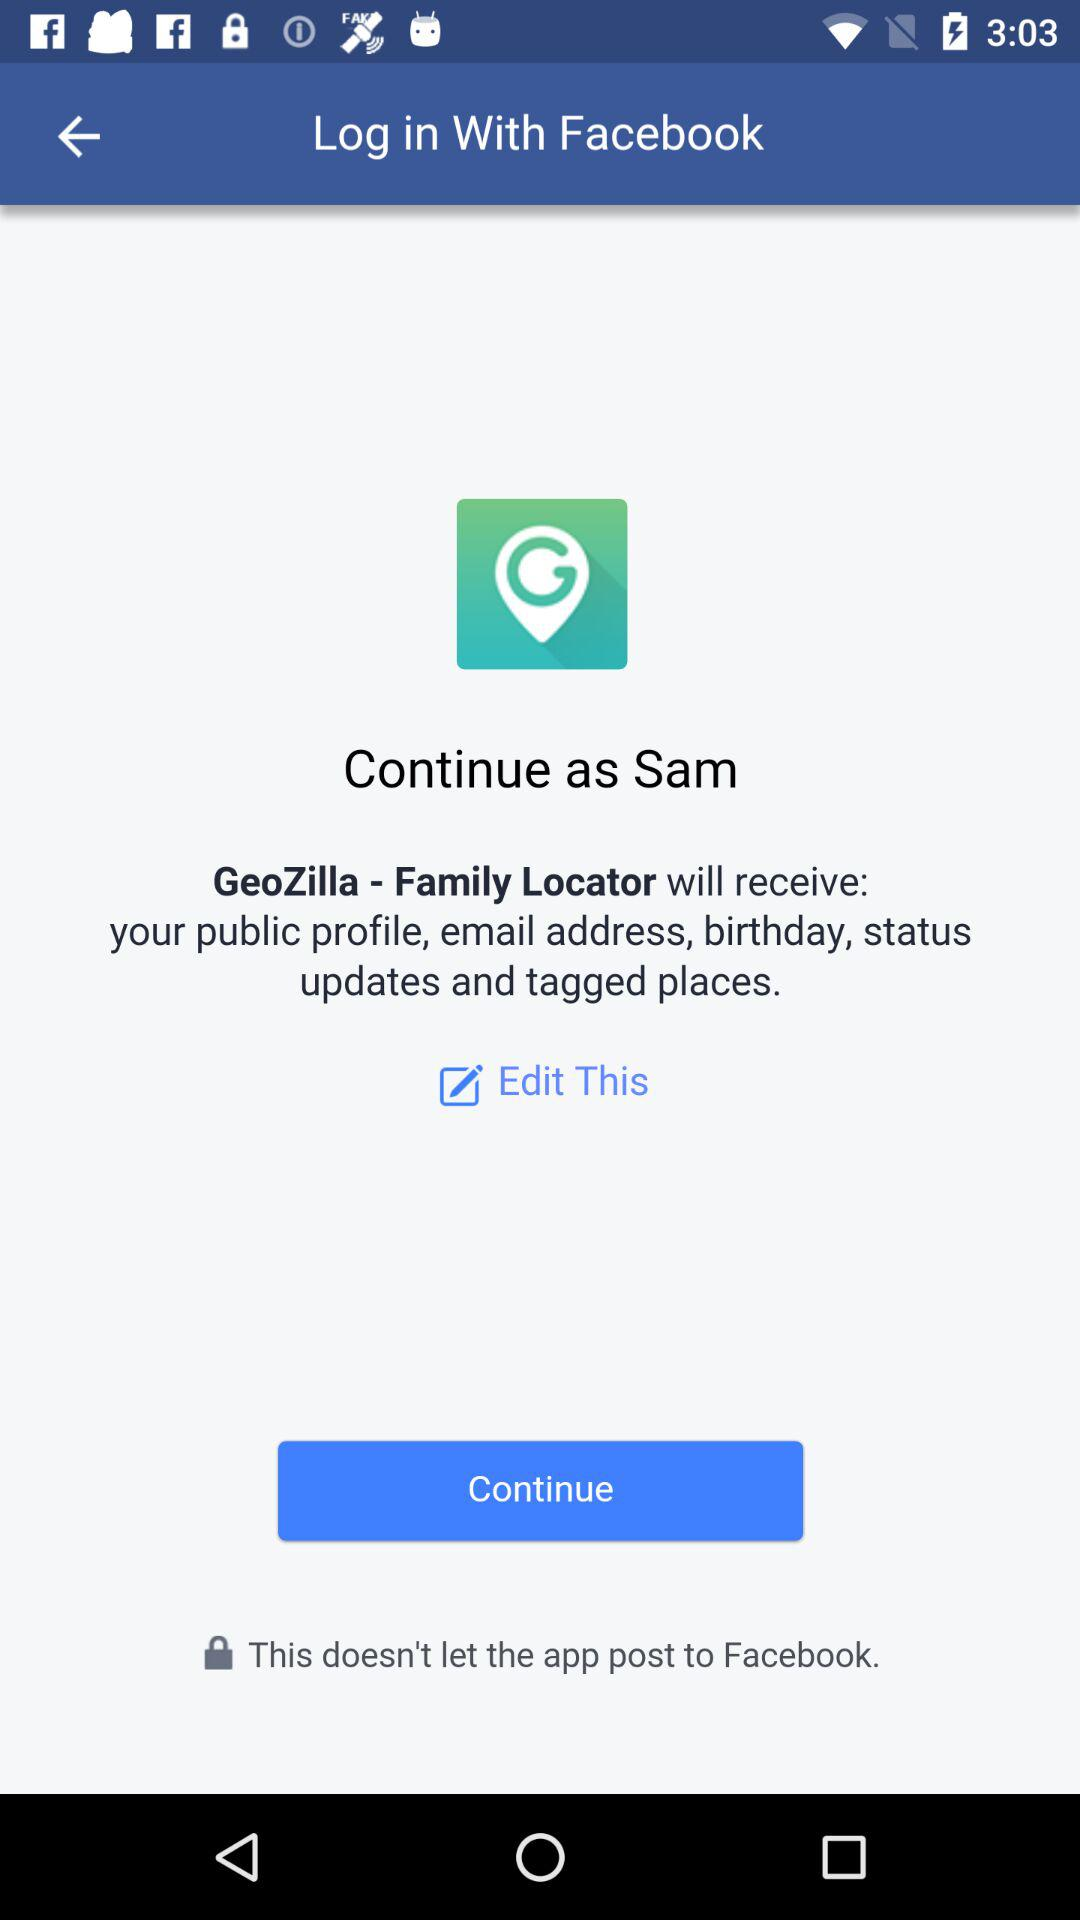What application will receive my public profile, email address, birthday, status updates, and tagged places? The application is "GeoZilla - Family Locator". 